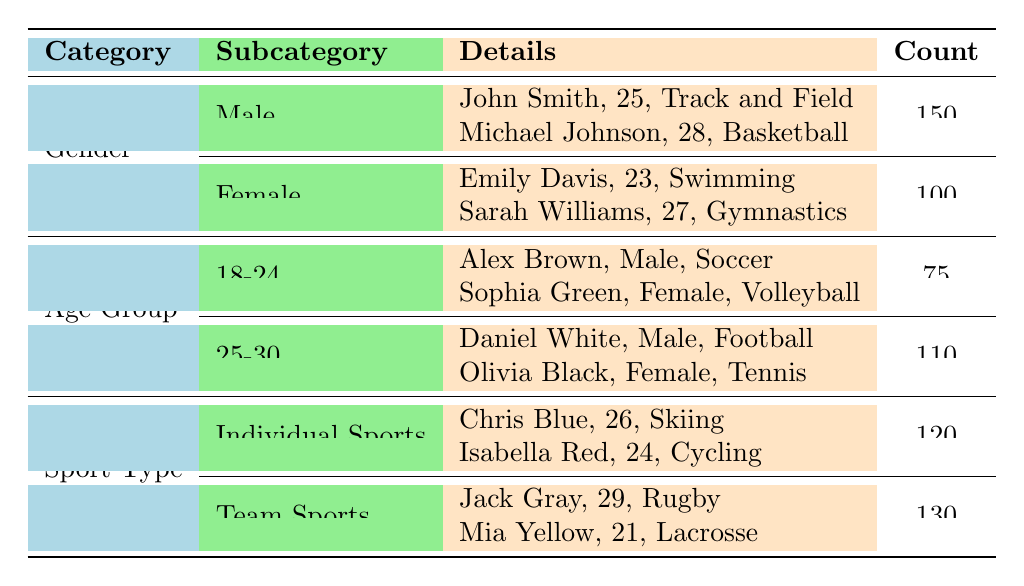What is the total count of male athletes receiving financial support? In the table, under the Gender category, the count for Male athletes is stated as 150.
Answer: 150 How many female athletes have completed their rehabilitation? Within the Female category, there are two individuals listed. Since only Emily Davis is marked as "Completed," the count is one.
Answer: 1 What is the average funding amount for athletes aged 25-30? The funding amounts for the two athletes in the 25-30 age group are $20,000 and $23,000. Adding these gives $43,000. Dividing by the 2 athletes gives an average of $21,500.
Answer: 21500 Is there a female athlete in individual sports? Reviewing the details in the Individual Sports category, there is Isabella Red listed, who is female and competes in Cycling.
Answer: Yes Which age group has the highest number of athletes receiving support, and what is that number? Comparing the counts of the age groups in the table, 110 athletes are in the 25-30 age group, and 75 are in the 18-24 group. Thus, the highest is 110 in the 25-30 age group.
Answer: 110 How many athletes in total are supported in team sports? The Team Sports category shows 130 athletes receiving support.
Answer: 130 Which sport has the highest funding amount awarded to an athlete? Analyzing the funding amounts in the table: Michael Johnson in Basketball received $20,000, Sarah Williams in Gymnastics received $22,000, and Olivia Black in Tennis received $23,000. The highest funding amount is $23,000 for Tennis.
Answer: 23000 What is the combined number of male athletes and athletes aged 18-24? The table indicates there are 150 male athletes and 75 athletes in the 18-24 age group. Summing these numbers gives 150 + 75 = 225.
Answer: 225 How many athletes are there in total across all categories? Counting the females (100) and males (150), then adding athletes from both age groups (75 + 110) and sport types (120 + 130) gives 150 + 100 + 75 + 110 + 120 + 130 = 685.
Answer: 685 